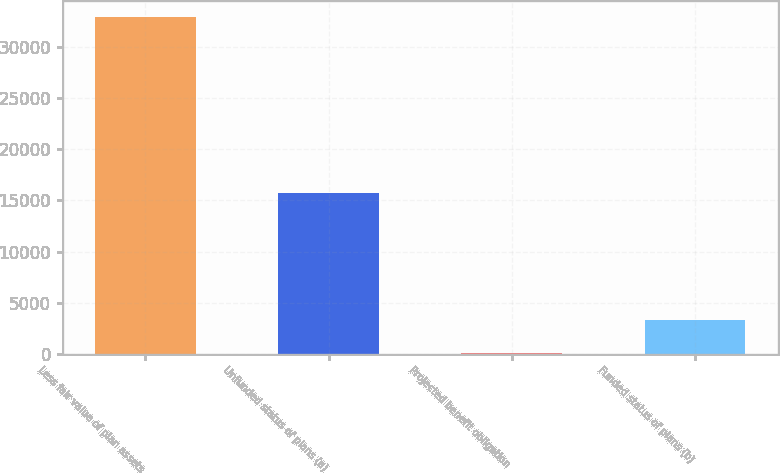Convert chart to OTSL. <chart><loc_0><loc_0><loc_500><loc_500><bar_chart><fcel>Less fair value of plan assets<fcel>Unfunded status of plans (a)<fcel>Projected benefit obligation<fcel>Funded status of plans (b)<nl><fcel>32925<fcel>15703<fcel>58<fcel>3344.7<nl></chart> 